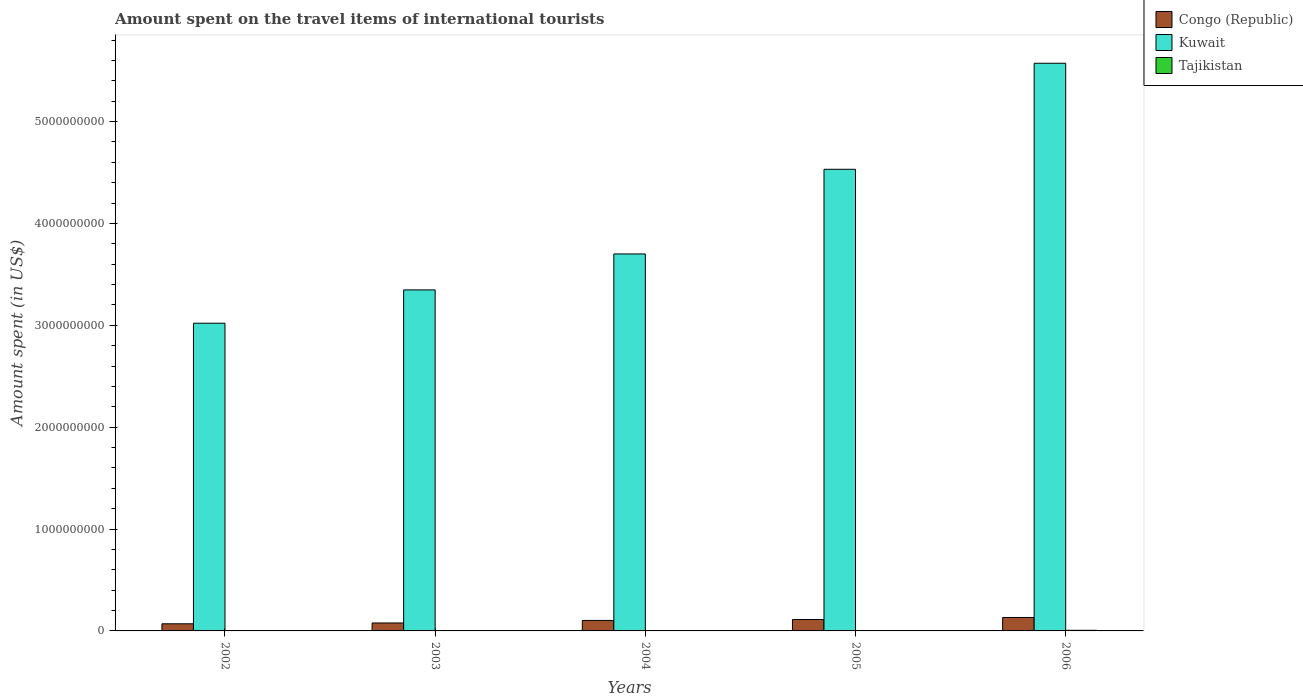How many groups of bars are there?
Offer a very short reply. 5. Are the number of bars on each tick of the X-axis equal?
Offer a terse response. Yes. What is the label of the 3rd group of bars from the left?
Keep it short and to the point. 2004. In how many cases, is the number of bars for a given year not equal to the number of legend labels?
Provide a short and direct response. 0. What is the amount spent on the travel items of international tourists in Kuwait in 2002?
Your answer should be very brief. 3.02e+09. Across all years, what is the minimum amount spent on the travel items of international tourists in Kuwait?
Ensure brevity in your answer.  3.02e+09. In which year was the amount spent on the travel items of international tourists in Congo (Republic) maximum?
Make the answer very short. 2006. What is the total amount spent on the travel items of international tourists in Congo (Republic) in the graph?
Keep it short and to the point. 4.95e+08. What is the difference between the amount spent on the travel items of international tourists in Congo (Republic) in 2004 and that in 2005?
Your answer should be very brief. -9.00e+06. What is the difference between the amount spent on the travel items of international tourists in Tajikistan in 2006 and the amount spent on the travel items of international tourists in Congo (Republic) in 2004?
Make the answer very short. -9.70e+07. What is the average amount spent on the travel items of international tourists in Congo (Republic) per year?
Your answer should be very brief. 9.90e+07. In the year 2006, what is the difference between the amount spent on the travel items of international tourists in Kuwait and amount spent on the travel items of international tourists in Tajikistan?
Offer a terse response. 5.57e+09. What is the ratio of the amount spent on the travel items of international tourists in Kuwait in 2003 to that in 2006?
Give a very brief answer. 0.6. Is the amount spent on the travel items of international tourists in Kuwait in 2003 less than that in 2006?
Keep it short and to the point. Yes. Is the difference between the amount spent on the travel items of international tourists in Kuwait in 2004 and 2005 greater than the difference between the amount spent on the travel items of international tourists in Tajikistan in 2004 and 2005?
Ensure brevity in your answer.  No. What is the difference between the highest and the second highest amount spent on the travel items of international tourists in Congo (Republic)?
Make the answer very short. 2.00e+07. What is the difference between the highest and the lowest amount spent on the travel items of international tourists in Tajikistan?
Your response must be concise. 4.30e+06. What does the 3rd bar from the left in 2002 represents?
Your response must be concise. Tajikistan. What does the 1st bar from the right in 2003 represents?
Your answer should be very brief. Tajikistan. Does the graph contain any zero values?
Your response must be concise. No. Where does the legend appear in the graph?
Ensure brevity in your answer.  Top right. How many legend labels are there?
Make the answer very short. 3. What is the title of the graph?
Provide a succinct answer. Amount spent on the travel items of international tourists. Does "Slovak Republic" appear as one of the legend labels in the graph?
Provide a succinct answer. No. What is the label or title of the X-axis?
Give a very brief answer. Years. What is the label or title of the Y-axis?
Keep it short and to the point. Amount spent (in US$). What is the Amount spent (in US$) in Congo (Republic) in 2002?
Your response must be concise. 7.00e+07. What is the Amount spent (in US$) of Kuwait in 2002?
Offer a very short reply. 3.02e+09. What is the Amount spent (in US$) in Tajikistan in 2002?
Offer a very short reply. 1.70e+06. What is the Amount spent (in US$) in Congo (Republic) in 2003?
Your response must be concise. 7.80e+07. What is the Amount spent (in US$) in Kuwait in 2003?
Your answer should be compact. 3.35e+09. What is the Amount spent (in US$) of Tajikistan in 2003?
Offer a terse response. 2.10e+06. What is the Amount spent (in US$) in Congo (Republic) in 2004?
Give a very brief answer. 1.03e+08. What is the Amount spent (in US$) of Kuwait in 2004?
Offer a very short reply. 3.70e+09. What is the Amount spent (in US$) in Tajikistan in 2004?
Give a very brief answer. 3.40e+06. What is the Amount spent (in US$) of Congo (Republic) in 2005?
Offer a terse response. 1.12e+08. What is the Amount spent (in US$) in Kuwait in 2005?
Offer a terse response. 4.53e+09. What is the Amount spent (in US$) of Tajikistan in 2005?
Provide a succinct answer. 3.80e+06. What is the Amount spent (in US$) in Congo (Republic) in 2006?
Give a very brief answer. 1.32e+08. What is the Amount spent (in US$) in Kuwait in 2006?
Offer a terse response. 5.57e+09. Across all years, what is the maximum Amount spent (in US$) in Congo (Republic)?
Ensure brevity in your answer.  1.32e+08. Across all years, what is the maximum Amount spent (in US$) of Kuwait?
Offer a terse response. 5.57e+09. Across all years, what is the maximum Amount spent (in US$) of Tajikistan?
Your answer should be very brief. 6.00e+06. Across all years, what is the minimum Amount spent (in US$) in Congo (Republic)?
Keep it short and to the point. 7.00e+07. Across all years, what is the minimum Amount spent (in US$) of Kuwait?
Provide a short and direct response. 3.02e+09. Across all years, what is the minimum Amount spent (in US$) in Tajikistan?
Offer a terse response. 1.70e+06. What is the total Amount spent (in US$) in Congo (Republic) in the graph?
Your answer should be compact. 4.95e+08. What is the total Amount spent (in US$) in Kuwait in the graph?
Provide a succinct answer. 2.02e+1. What is the total Amount spent (in US$) of Tajikistan in the graph?
Provide a succinct answer. 1.70e+07. What is the difference between the Amount spent (in US$) in Congo (Republic) in 2002 and that in 2003?
Offer a very short reply. -8.00e+06. What is the difference between the Amount spent (in US$) of Kuwait in 2002 and that in 2003?
Provide a short and direct response. -3.27e+08. What is the difference between the Amount spent (in US$) in Tajikistan in 2002 and that in 2003?
Provide a succinct answer. -4.00e+05. What is the difference between the Amount spent (in US$) in Congo (Republic) in 2002 and that in 2004?
Provide a succinct answer. -3.30e+07. What is the difference between the Amount spent (in US$) of Kuwait in 2002 and that in 2004?
Your response must be concise. -6.80e+08. What is the difference between the Amount spent (in US$) in Tajikistan in 2002 and that in 2004?
Give a very brief answer. -1.70e+06. What is the difference between the Amount spent (in US$) of Congo (Republic) in 2002 and that in 2005?
Your answer should be compact. -4.20e+07. What is the difference between the Amount spent (in US$) of Kuwait in 2002 and that in 2005?
Provide a short and direct response. -1.51e+09. What is the difference between the Amount spent (in US$) of Tajikistan in 2002 and that in 2005?
Give a very brief answer. -2.10e+06. What is the difference between the Amount spent (in US$) of Congo (Republic) in 2002 and that in 2006?
Your answer should be compact. -6.20e+07. What is the difference between the Amount spent (in US$) in Kuwait in 2002 and that in 2006?
Provide a succinct answer. -2.55e+09. What is the difference between the Amount spent (in US$) of Tajikistan in 2002 and that in 2006?
Keep it short and to the point. -4.30e+06. What is the difference between the Amount spent (in US$) of Congo (Republic) in 2003 and that in 2004?
Offer a very short reply. -2.50e+07. What is the difference between the Amount spent (in US$) in Kuwait in 2003 and that in 2004?
Give a very brief answer. -3.53e+08. What is the difference between the Amount spent (in US$) of Tajikistan in 2003 and that in 2004?
Make the answer very short. -1.30e+06. What is the difference between the Amount spent (in US$) in Congo (Republic) in 2003 and that in 2005?
Keep it short and to the point. -3.40e+07. What is the difference between the Amount spent (in US$) of Kuwait in 2003 and that in 2005?
Ensure brevity in your answer.  -1.18e+09. What is the difference between the Amount spent (in US$) in Tajikistan in 2003 and that in 2005?
Your answer should be very brief. -1.70e+06. What is the difference between the Amount spent (in US$) of Congo (Republic) in 2003 and that in 2006?
Your answer should be compact. -5.40e+07. What is the difference between the Amount spent (in US$) in Kuwait in 2003 and that in 2006?
Keep it short and to the point. -2.22e+09. What is the difference between the Amount spent (in US$) of Tajikistan in 2003 and that in 2006?
Provide a succinct answer. -3.90e+06. What is the difference between the Amount spent (in US$) in Congo (Republic) in 2004 and that in 2005?
Provide a succinct answer. -9.00e+06. What is the difference between the Amount spent (in US$) of Kuwait in 2004 and that in 2005?
Your answer should be compact. -8.31e+08. What is the difference between the Amount spent (in US$) of Tajikistan in 2004 and that in 2005?
Ensure brevity in your answer.  -4.00e+05. What is the difference between the Amount spent (in US$) in Congo (Republic) in 2004 and that in 2006?
Your response must be concise. -2.90e+07. What is the difference between the Amount spent (in US$) in Kuwait in 2004 and that in 2006?
Offer a terse response. -1.87e+09. What is the difference between the Amount spent (in US$) in Tajikistan in 2004 and that in 2006?
Keep it short and to the point. -2.60e+06. What is the difference between the Amount spent (in US$) of Congo (Republic) in 2005 and that in 2006?
Offer a terse response. -2.00e+07. What is the difference between the Amount spent (in US$) of Kuwait in 2005 and that in 2006?
Your answer should be very brief. -1.04e+09. What is the difference between the Amount spent (in US$) of Tajikistan in 2005 and that in 2006?
Provide a short and direct response. -2.20e+06. What is the difference between the Amount spent (in US$) of Congo (Republic) in 2002 and the Amount spent (in US$) of Kuwait in 2003?
Offer a terse response. -3.28e+09. What is the difference between the Amount spent (in US$) in Congo (Republic) in 2002 and the Amount spent (in US$) in Tajikistan in 2003?
Your response must be concise. 6.79e+07. What is the difference between the Amount spent (in US$) of Kuwait in 2002 and the Amount spent (in US$) of Tajikistan in 2003?
Keep it short and to the point. 3.02e+09. What is the difference between the Amount spent (in US$) in Congo (Republic) in 2002 and the Amount spent (in US$) in Kuwait in 2004?
Your response must be concise. -3.63e+09. What is the difference between the Amount spent (in US$) in Congo (Republic) in 2002 and the Amount spent (in US$) in Tajikistan in 2004?
Keep it short and to the point. 6.66e+07. What is the difference between the Amount spent (in US$) of Kuwait in 2002 and the Amount spent (in US$) of Tajikistan in 2004?
Provide a succinct answer. 3.02e+09. What is the difference between the Amount spent (in US$) in Congo (Republic) in 2002 and the Amount spent (in US$) in Kuwait in 2005?
Offer a terse response. -4.46e+09. What is the difference between the Amount spent (in US$) in Congo (Republic) in 2002 and the Amount spent (in US$) in Tajikistan in 2005?
Provide a succinct answer. 6.62e+07. What is the difference between the Amount spent (in US$) of Kuwait in 2002 and the Amount spent (in US$) of Tajikistan in 2005?
Ensure brevity in your answer.  3.02e+09. What is the difference between the Amount spent (in US$) in Congo (Republic) in 2002 and the Amount spent (in US$) in Kuwait in 2006?
Ensure brevity in your answer.  -5.50e+09. What is the difference between the Amount spent (in US$) in Congo (Republic) in 2002 and the Amount spent (in US$) in Tajikistan in 2006?
Keep it short and to the point. 6.40e+07. What is the difference between the Amount spent (in US$) of Kuwait in 2002 and the Amount spent (in US$) of Tajikistan in 2006?
Ensure brevity in your answer.  3.02e+09. What is the difference between the Amount spent (in US$) of Congo (Republic) in 2003 and the Amount spent (in US$) of Kuwait in 2004?
Keep it short and to the point. -3.62e+09. What is the difference between the Amount spent (in US$) in Congo (Republic) in 2003 and the Amount spent (in US$) in Tajikistan in 2004?
Keep it short and to the point. 7.46e+07. What is the difference between the Amount spent (in US$) of Kuwait in 2003 and the Amount spent (in US$) of Tajikistan in 2004?
Keep it short and to the point. 3.34e+09. What is the difference between the Amount spent (in US$) of Congo (Republic) in 2003 and the Amount spent (in US$) of Kuwait in 2005?
Provide a succinct answer. -4.45e+09. What is the difference between the Amount spent (in US$) in Congo (Republic) in 2003 and the Amount spent (in US$) in Tajikistan in 2005?
Keep it short and to the point. 7.42e+07. What is the difference between the Amount spent (in US$) of Kuwait in 2003 and the Amount spent (in US$) of Tajikistan in 2005?
Give a very brief answer. 3.34e+09. What is the difference between the Amount spent (in US$) in Congo (Republic) in 2003 and the Amount spent (in US$) in Kuwait in 2006?
Ensure brevity in your answer.  -5.50e+09. What is the difference between the Amount spent (in US$) in Congo (Republic) in 2003 and the Amount spent (in US$) in Tajikistan in 2006?
Give a very brief answer. 7.20e+07. What is the difference between the Amount spent (in US$) in Kuwait in 2003 and the Amount spent (in US$) in Tajikistan in 2006?
Your response must be concise. 3.34e+09. What is the difference between the Amount spent (in US$) of Congo (Republic) in 2004 and the Amount spent (in US$) of Kuwait in 2005?
Make the answer very short. -4.43e+09. What is the difference between the Amount spent (in US$) of Congo (Republic) in 2004 and the Amount spent (in US$) of Tajikistan in 2005?
Your answer should be compact. 9.92e+07. What is the difference between the Amount spent (in US$) in Kuwait in 2004 and the Amount spent (in US$) in Tajikistan in 2005?
Offer a very short reply. 3.70e+09. What is the difference between the Amount spent (in US$) in Congo (Republic) in 2004 and the Amount spent (in US$) in Kuwait in 2006?
Give a very brief answer. -5.47e+09. What is the difference between the Amount spent (in US$) in Congo (Republic) in 2004 and the Amount spent (in US$) in Tajikistan in 2006?
Make the answer very short. 9.70e+07. What is the difference between the Amount spent (in US$) of Kuwait in 2004 and the Amount spent (in US$) of Tajikistan in 2006?
Offer a very short reply. 3.70e+09. What is the difference between the Amount spent (in US$) in Congo (Republic) in 2005 and the Amount spent (in US$) in Kuwait in 2006?
Offer a terse response. -5.46e+09. What is the difference between the Amount spent (in US$) in Congo (Republic) in 2005 and the Amount spent (in US$) in Tajikistan in 2006?
Make the answer very short. 1.06e+08. What is the difference between the Amount spent (in US$) in Kuwait in 2005 and the Amount spent (in US$) in Tajikistan in 2006?
Offer a terse response. 4.53e+09. What is the average Amount spent (in US$) of Congo (Republic) per year?
Make the answer very short. 9.90e+07. What is the average Amount spent (in US$) in Kuwait per year?
Your response must be concise. 4.04e+09. What is the average Amount spent (in US$) in Tajikistan per year?
Your answer should be very brief. 3.40e+06. In the year 2002, what is the difference between the Amount spent (in US$) of Congo (Republic) and Amount spent (in US$) of Kuwait?
Give a very brief answer. -2.95e+09. In the year 2002, what is the difference between the Amount spent (in US$) in Congo (Republic) and Amount spent (in US$) in Tajikistan?
Keep it short and to the point. 6.83e+07. In the year 2002, what is the difference between the Amount spent (in US$) of Kuwait and Amount spent (in US$) of Tajikistan?
Your answer should be compact. 3.02e+09. In the year 2003, what is the difference between the Amount spent (in US$) of Congo (Republic) and Amount spent (in US$) of Kuwait?
Provide a short and direct response. -3.27e+09. In the year 2003, what is the difference between the Amount spent (in US$) in Congo (Republic) and Amount spent (in US$) in Tajikistan?
Ensure brevity in your answer.  7.59e+07. In the year 2003, what is the difference between the Amount spent (in US$) of Kuwait and Amount spent (in US$) of Tajikistan?
Offer a very short reply. 3.35e+09. In the year 2004, what is the difference between the Amount spent (in US$) of Congo (Republic) and Amount spent (in US$) of Kuwait?
Give a very brief answer. -3.60e+09. In the year 2004, what is the difference between the Amount spent (in US$) in Congo (Republic) and Amount spent (in US$) in Tajikistan?
Keep it short and to the point. 9.96e+07. In the year 2004, what is the difference between the Amount spent (in US$) in Kuwait and Amount spent (in US$) in Tajikistan?
Offer a very short reply. 3.70e+09. In the year 2005, what is the difference between the Amount spent (in US$) in Congo (Republic) and Amount spent (in US$) in Kuwait?
Your response must be concise. -4.42e+09. In the year 2005, what is the difference between the Amount spent (in US$) in Congo (Republic) and Amount spent (in US$) in Tajikistan?
Your answer should be compact. 1.08e+08. In the year 2005, what is the difference between the Amount spent (in US$) of Kuwait and Amount spent (in US$) of Tajikistan?
Offer a very short reply. 4.53e+09. In the year 2006, what is the difference between the Amount spent (in US$) of Congo (Republic) and Amount spent (in US$) of Kuwait?
Your answer should be very brief. -5.44e+09. In the year 2006, what is the difference between the Amount spent (in US$) of Congo (Republic) and Amount spent (in US$) of Tajikistan?
Provide a short and direct response. 1.26e+08. In the year 2006, what is the difference between the Amount spent (in US$) of Kuwait and Amount spent (in US$) of Tajikistan?
Your response must be concise. 5.57e+09. What is the ratio of the Amount spent (in US$) in Congo (Republic) in 2002 to that in 2003?
Give a very brief answer. 0.9. What is the ratio of the Amount spent (in US$) of Kuwait in 2002 to that in 2003?
Offer a very short reply. 0.9. What is the ratio of the Amount spent (in US$) of Tajikistan in 2002 to that in 2003?
Offer a terse response. 0.81. What is the ratio of the Amount spent (in US$) of Congo (Republic) in 2002 to that in 2004?
Offer a very short reply. 0.68. What is the ratio of the Amount spent (in US$) of Kuwait in 2002 to that in 2004?
Provide a short and direct response. 0.82. What is the ratio of the Amount spent (in US$) in Kuwait in 2002 to that in 2005?
Offer a very short reply. 0.67. What is the ratio of the Amount spent (in US$) in Tajikistan in 2002 to that in 2005?
Provide a short and direct response. 0.45. What is the ratio of the Amount spent (in US$) in Congo (Republic) in 2002 to that in 2006?
Make the answer very short. 0.53. What is the ratio of the Amount spent (in US$) in Kuwait in 2002 to that in 2006?
Your response must be concise. 0.54. What is the ratio of the Amount spent (in US$) in Tajikistan in 2002 to that in 2006?
Your response must be concise. 0.28. What is the ratio of the Amount spent (in US$) in Congo (Republic) in 2003 to that in 2004?
Your answer should be compact. 0.76. What is the ratio of the Amount spent (in US$) in Kuwait in 2003 to that in 2004?
Keep it short and to the point. 0.9. What is the ratio of the Amount spent (in US$) in Tajikistan in 2003 to that in 2004?
Ensure brevity in your answer.  0.62. What is the ratio of the Amount spent (in US$) of Congo (Republic) in 2003 to that in 2005?
Your response must be concise. 0.7. What is the ratio of the Amount spent (in US$) of Kuwait in 2003 to that in 2005?
Keep it short and to the point. 0.74. What is the ratio of the Amount spent (in US$) in Tajikistan in 2003 to that in 2005?
Your answer should be compact. 0.55. What is the ratio of the Amount spent (in US$) in Congo (Republic) in 2003 to that in 2006?
Your answer should be compact. 0.59. What is the ratio of the Amount spent (in US$) of Kuwait in 2003 to that in 2006?
Ensure brevity in your answer.  0.6. What is the ratio of the Amount spent (in US$) in Tajikistan in 2003 to that in 2006?
Your answer should be compact. 0.35. What is the ratio of the Amount spent (in US$) in Congo (Republic) in 2004 to that in 2005?
Offer a very short reply. 0.92. What is the ratio of the Amount spent (in US$) in Kuwait in 2004 to that in 2005?
Give a very brief answer. 0.82. What is the ratio of the Amount spent (in US$) in Tajikistan in 2004 to that in 2005?
Provide a succinct answer. 0.89. What is the ratio of the Amount spent (in US$) of Congo (Republic) in 2004 to that in 2006?
Your answer should be very brief. 0.78. What is the ratio of the Amount spent (in US$) in Kuwait in 2004 to that in 2006?
Provide a short and direct response. 0.66. What is the ratio of the Amount spent (in US$) of Tajikistan in 2004 to that in 2006?
Your response must be concise. 0.57. What is the ratio of the Amount spent (in US$) of Congo (Republic) in 2005 to that in 2006?
Provide a succinct answer. 0.85. What is the ratio of the Amount spent (in US$) in Kuwait in 2005 to that in 2006?
Provide a short and direct response. 0.81. What is the ratio of the Amount spent (in US$) of Tajikistan in 2005 to that in 2006?
Provide a short and direct response. 0.63. What is the difference between the highest and the second highest Amount spent (in US$) in Congo (Republic)?
Provide a succinct answer. 2.00e+07. What is the difference between the highest and the second highest Amount spent (in US$) in Kuwait?
Provide a short and direct response. 1.04e+09. What is the difference between the highest and the second highest Amount spent (in US$) in Tajikistan?
Offer a very short reply. 2.20e+06. What is the difference between the highest and the lowest Amount spent (in US$) of Congo (Republic)?
Make the answer very short. 6.20e+07. What is the difference between the highest and the lowest Amount spent (in US$) of Kuwait?
Provide a succinct answer. 2.55e+09. What is the difference between the highest and the lowest Amount spent (in US$) in Tajikistan?
Keep it short and to the point. 4.30e+06. 